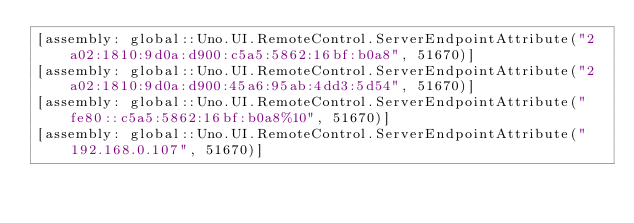Convert code to text. <code><loc_0><loc_0><loc_500><loc_500><_C#_>[assembly: global::Uno.UI.RemoteControl.ServerEndpointAttribute("2a02:1810:9d0a:d900:c5a5:5862:16bf:b0a8", 51670)]
[assembly: global::Uno.UI.RemoteControl.ServerEndpointAttribute("2a02:1810:9d0a:d900:45a6:95ab:4dd3:5d54", 51670)]
[assembly: global::Uno.UI.RemoteControl.ServerEndpointAttribute("fe80::c5a5:5862:16bf:b0a8%10", 51670)]
[assembly: global::Uno.UI.RemoteControl.ServerEndpointAttribute("192.168.0.107", 51670)]</code> 